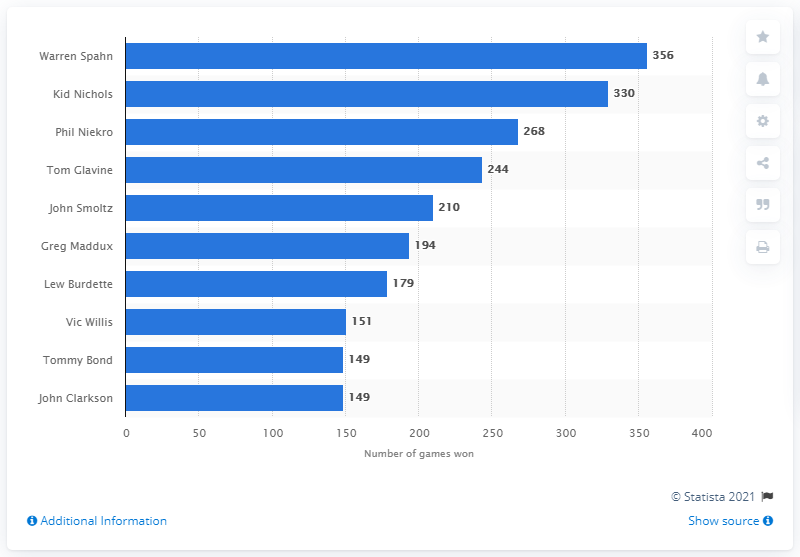Give some essential details in this illustration. Warren Spahn has won a grand total of 356 games throughout his illustrious baseball career, cementing his status as one of the all-time greats. 